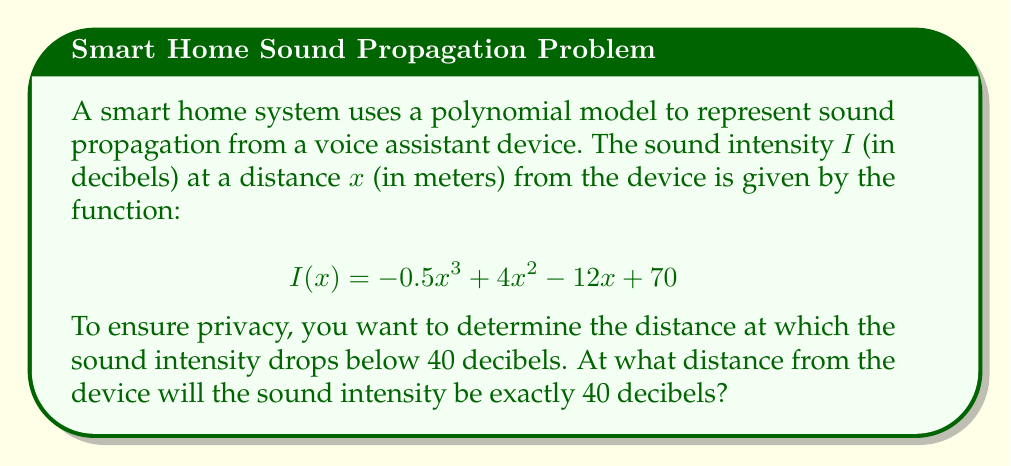What is the answer to this math problem? To solve this problem, we need to find the value of $x$ where $I(x) = 40$. Let's approach this step-by-step:

1) Set up the equation:
   $$-0.5x^3 + 4x^2 - 12x + 70 = 40$$

2) Rearrange the equation to standard form:
   $$-0.5x^3 + 4x^2 - 12x + 30 = 0$$

3) This is a cubic equation. It can be solved using the rational root theorem or by factoring.

4) Let's try factoring:
   $$-0.5(x^3 - 8x^2 + 24x - 60) = 0$$
   $$-0.5(x - 6)(x^2 - 2x + 10) = 0$$

5) The solutions to this equation are:
   $x = 6$ or $x^2 - 2x + 10 = 0$

6) The quadratic part $(x^2 - 2x + 10 = 0)$ has no real roots, as its discriminant is negative.

7) Therefore, the only real solution is $x = 6$.

8) To verify, let's plug this back into the original function:
   $$I(6) = -0.5(6)^3 + 4(6)^2 - 12(6) + 70$$
   $$= -108 + 144 - 72 + 70 = 40$$

Thus, the sound intensity will be exactly 40 decibels at a distance of 6 meters from the device.
Answer: 6 meters 